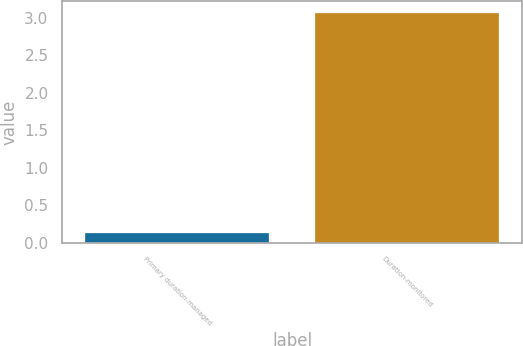Convert chart. <chart><loc_0><loc_0><loc_500><loc_500><bar_chart><fcel>Primary duration-managed<fcel>Duration-monitored<nl><fcel>0.13<fcel>3.07<nl></chart> 